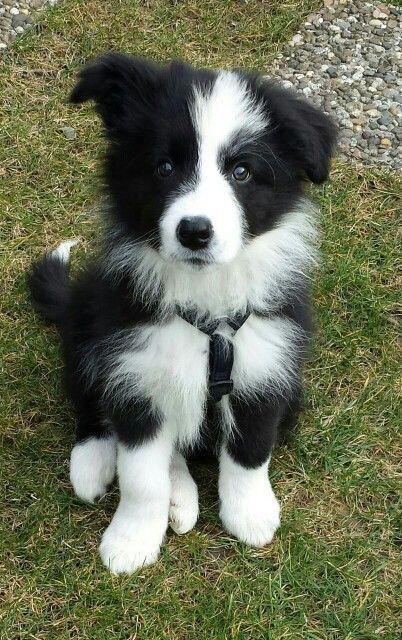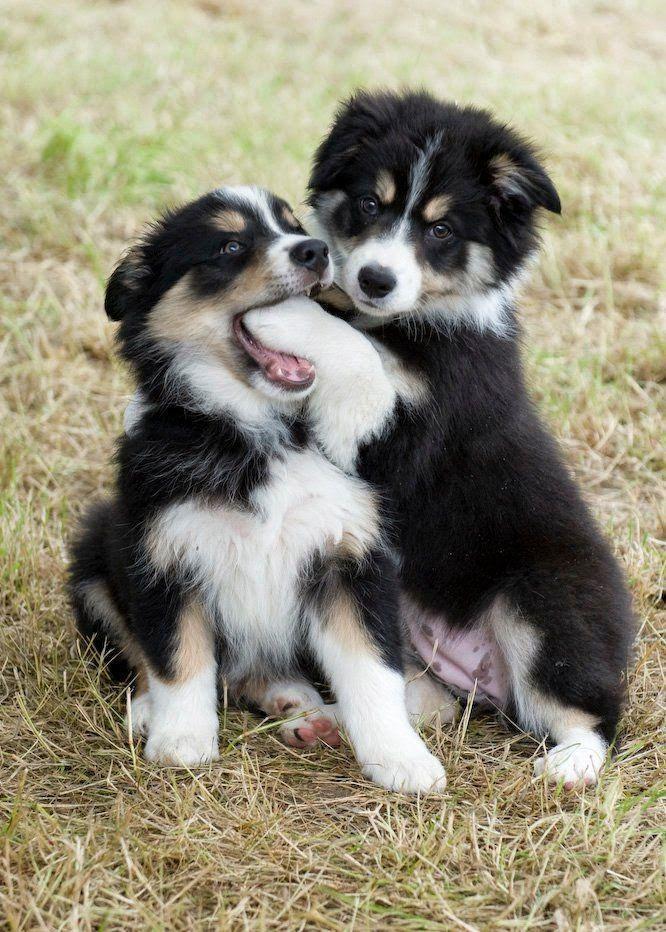The first image is the image on the left, the second image is the image on the right. For the images displayed, is the sentence "There are two dogs in total." factually correct? Answer yes or no. No. 